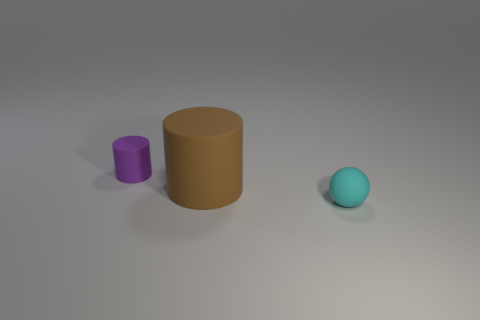Add 2 tiny purple objects. How many objects exist? 5 Subtract 1 cylinders. How many cylinders are left? 1 Subtract all purple cylinders. How many cylinders are left? 1 Subtract all spheres. How many objects are left? 2 Subtract 1 cyan balls. How many objects are left? 2 Subtract all blue spheres. Subtract all gray cylinders. How many spheres are left? 1 Subtract all gray cubes. How many brown spheres are left? 0 Subtract all cyan shiny things. Subtract all large brown things. How many objects are left? 2 Add 3 cyan balls. How many cyan balls are left? 4 Add 2 yellow matte balls. How many yellow matte balls exist? 2 